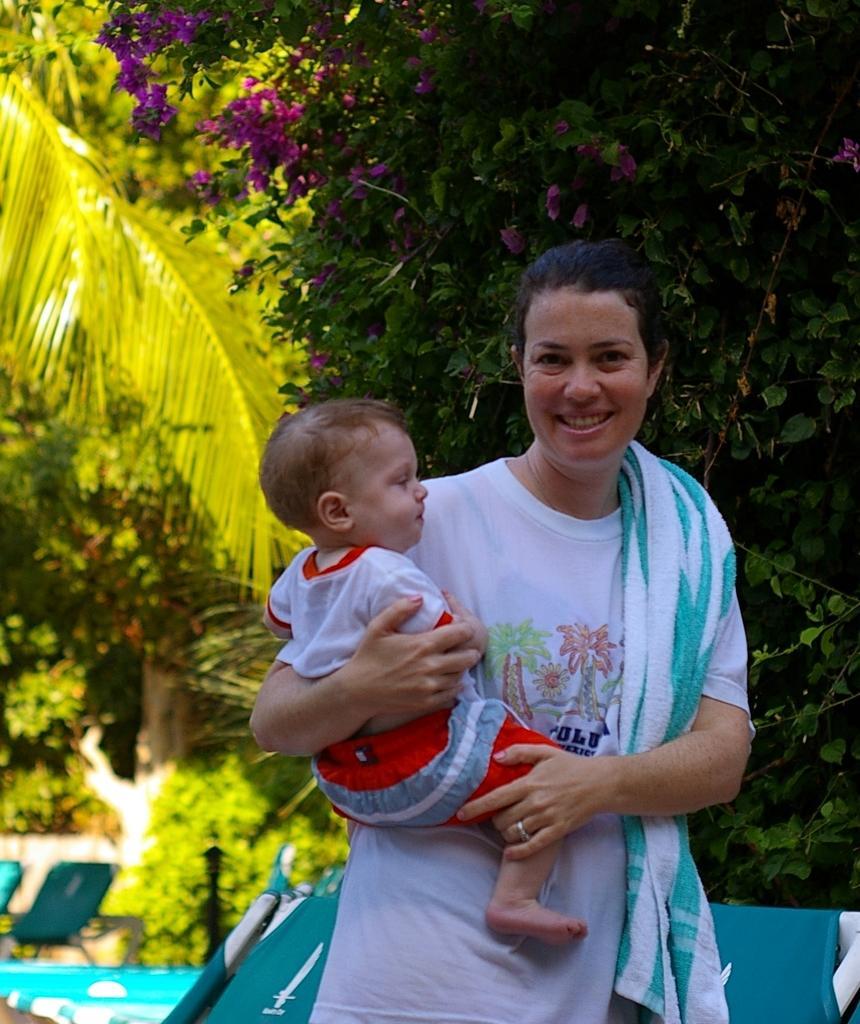Please provide a concise description of this image. In this image there is a woman standing with a smile on her face, there is a towel on her shoulder and she is holding a baby, behind her there are few chairs, trees and plants. 